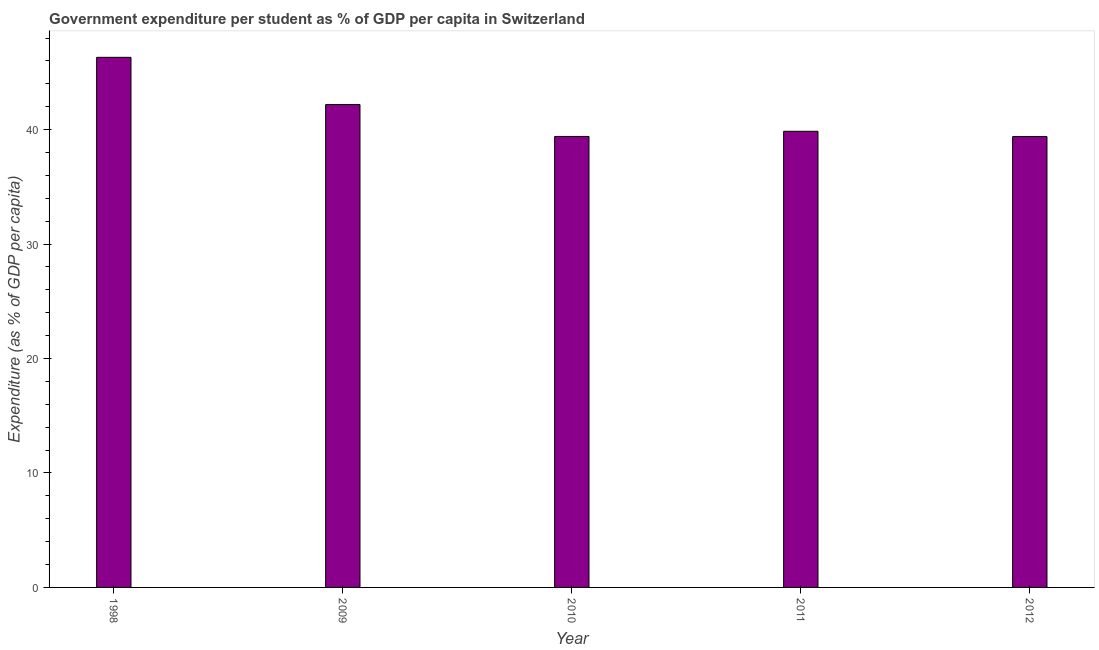Does the graph contain any zero values?
Keep it short and to the point. No. What is the title of the graph?
Ensure brevity in your answer.  Government expenditure per student as % of GDP per capita in Switzerland. What is the label or title of the X-axis?
Make the answer very short. Year. What is the label or title of the Y-axis?
Provide a short and direct response. Expenditure (as % of GDP per capita). What is the government expenditure per student in 2012?
Ensure brevity in your answer.  39.4. Across all years, what is the maximum government expenditure per student?
Make the answer very short. 46.32. Across all years, what is the minimum government expenditure per student?
Give a very brief answer. 39.4. What is the sum of the government expenditure per student?
Offer a terse response. 207.17. What is the difference between the government expenditure per student in 2009 and 2011?
Keep it short and to the point. 2.33. What is the average government expenditure per student per year?
Offer a terse response. 41.43. What is the median government expenditure per student?
Keep it short and to the point. 39.86. In how many years, is the government expenditure per student greater than 22 %?
Make the answer very short. 5. Do a majority of the years between 2009 and 2012 (inclusive) have government expenditure per student greater than 2 %?
Provide a short and direct response. Yes. What is the ratio of the government expenditure per student in 2009 to that in 2011?
Make the answer very short. 1.06. Is the government expenditure per student in 2010 less than that in 2012?
Make the answer very short. No. Is the difference between the government expenditure per student in 1998 and 2011 greater than the difference between any two years?
Provide a succinct answer. No. What is the difference between the highest and the second highest government expenditure per student?
Provide a succinct answer. 4.13. Is the sum of the government expenditure per student in 2009 and 2011 greater than the maximum government expenditure per student across all years?
Ensure brevity in your answer.  Yes. What is the difference between the highest and the lowest government expenditure per student?
Offer a terse response. 6.92. How many years are there in the graph?
Your answer should be compact. 5. What is the Expenditure (as % of GDP per capita) in 1998?
Provide a short and direct response. 46.32. What is the Expenditure (as % of GDP per capita) of 2009?
Your answer should be very brief. 42.19. What is the Expenditure (as % of GDP per capita) of 2010?
Ensure brevity in your answer.  39.41. What is the Expenditure (as % of GDP per capita) in 2011?
Provide a succinct answer. 39.86. What is the Expenditure (as % of GDP per capita) of 2012?
Ensure brevity in your answer.  39.4. What is the difference between the Expenditure (as % of GDP per capita) in 1998 and 2009?
Ensure brevity in your answer.  4.13. What is the difference between the Expenditure (as % of GDP per capita) in 1998 and 2010?
Give a very brief answer. 6.91. What is the difference between the Expenditure (as % of GDP per capita) in 1998 and 2011?
Give a very brief answer. 6.46. What is the difference between the Expenditure (as % of GDP per capita) in 1998 and 2012?
Give a very brief answer. 6.92. What is the difference between the Expenditure (as % of GDP per capita) in 2009 and 2010?
Keep it short and to the point. 2.79. What is the difference between the Expenditure (as % of GDP per capita) in 2009 and 2011?
Keep it short and to the point. 2.33. What is the difference between the Expenditure (as % of GDP per capita) in 2009 and 2012?
Your answer should be very brief. 2.8. What is the difference between the Expenditure (as % of GDP per capita) in 2010 and 2011?
Offer a terse response. -0.45. What is the difference between the Expenditure (as % of GDP per capita) in 2010 and 2012?
Your answer should be compact. 0.01. What is the difference between the Expenditure (as % of GDP per capita) in 2011 and 2012?
Provide a succinct answer. 0.46. What is the ratio of the Expenditure (as % of GDP per capita) in 1998 to that in 2009?
Ensure brevity in your answer.  1.1. What is the ratio of the Expenditure (as % of GDP per capita) in 1998 to that in 2010?
Keep it short and to the point. 1.18. What is the ratio of the Expenditure (as % of GDP per capita) in 1998 to that in 2011?
Ensure brevity in your answer.  1.16. What is the ratio of the Expenditure (as % of GDP per capita) in 1998 to that in 2012?
Provide a short and direct response. 1.18. What is the ratio of the Expenditure (as % of GDP per capita) in 2009 to that in 2010?
Make the answer very short. 1.07. What is the ratio of the Expenditure (as % of GDP per capita) in 2009 to that in 2011?
Your answer should be very brief. 1.06. What is the ratio of the Expenditure (as % of GDP per capita) in 2009 to that in 2012?
Offer a very short reply. 1.07. What is the ratio of the Expenditure (as % of GDP per capita) in 2010 to that in 2011?
Ensure brevity in your answer.  0.99. What is the ratio of the Expenditure (as % of GDP per capita) in 2010 to that in 2012?
Make the answer very short. 1. What is the ratio of the Expenditure (as % of GDP per capita) in 2011 to that in 2012?
Your answer should be very brief. 1.01. 